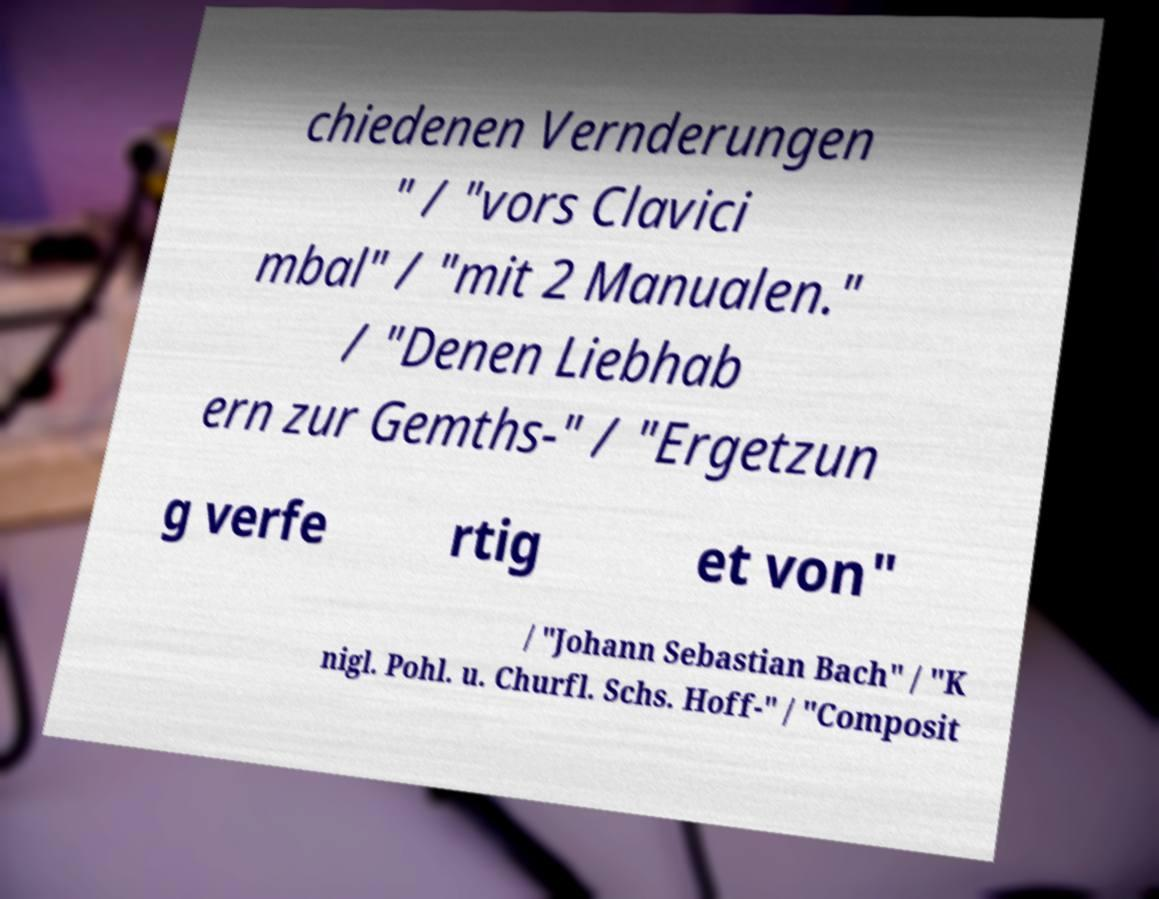Please identify and transcribe the text found in this image. chiedenen Vernderungen " / "vors Clavici mbal" / "mit 2 Manualen." / "Denen Liebhab ern zur Gemths-" / "Ergetzun g verfe rtig et von" / "Johann Sebastian Bach" / "K nigl. Pohl. u. Churfl. Schs. Hoff-" / "Composit 